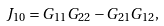<formula> <loc_0><loc_0><loc_500><loc_500>J _ { 1 0 } = G _ { 1 1 } G _ { 2 2 } - G _ { 2 1 } G _ { 1 2 } ,</formula> 